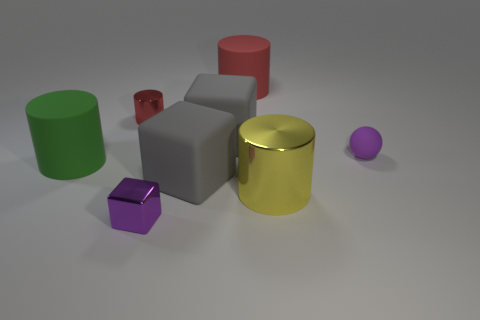Is the number of small red things less than the number of gray blocks?
Your answer should be very brief. Yes. There is a tiny rubber thing that is behind the big green cylinder; what color is it?
Give a very brief answer. Purple. What is the cylinder that is in front of the tiny metallic cylinder and to the right of the tiny red metallic object made of?
Your answer should be very brief. Metal. The small red thing that is the same material as the big yellow thing is what shape?
Offer a very short reply. Cylinder. There is a red cylinder in front of the large red cylinder; what number of yellow shiny cylinders are behind it?
Keep it short and to the point. 0. What number of objects are both in front of the small rubber thing and left of the small metal block?
Provide a succinct answer. 1. How many other objects are there of the same material as the green cylinder?
Provide a succinct answer. 4. There is a small object right of the large cylinder that is behind the matte ball; what color is it?
Offer a very short reply. Purple. Do the rubber thing that is on the right side of the yellow cylinder and the big metallic thing have the same color?
Ensure brevity in your answer.  No. Do the purple rubber sphere and the yellow cylinder have the same size?
Offer a terse response. No. 